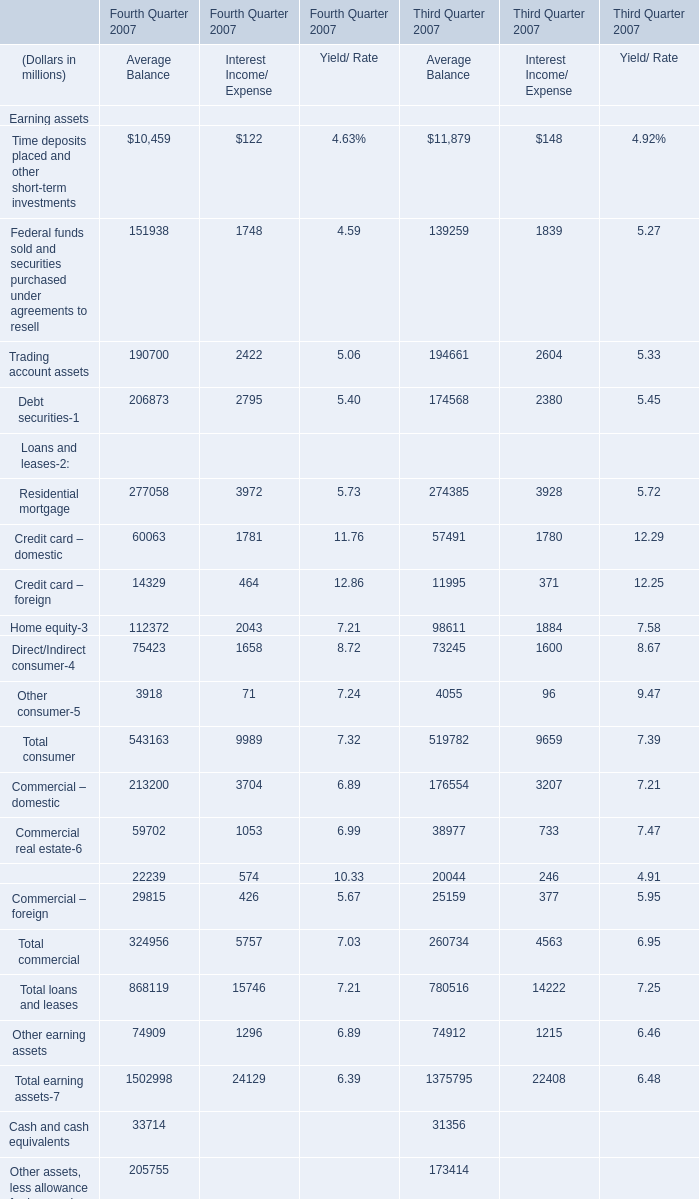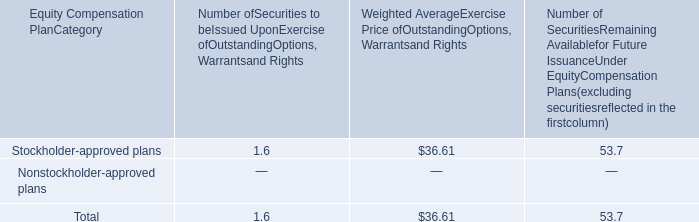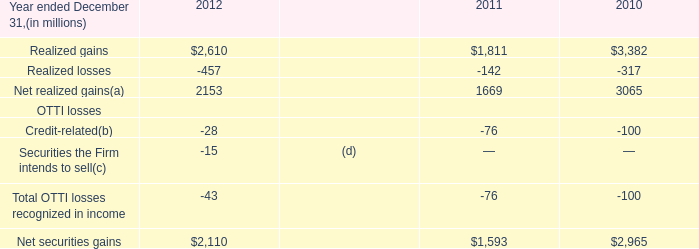What is the difference between the greatest Residential mortgage in Fourth Quarter 2007 and Third Quarter 2007？ (in million) 
Computations: (((277058 + 3972) + 5.73) - ((274385 + 3928) + 5.72))
Answer: 2717.01. 